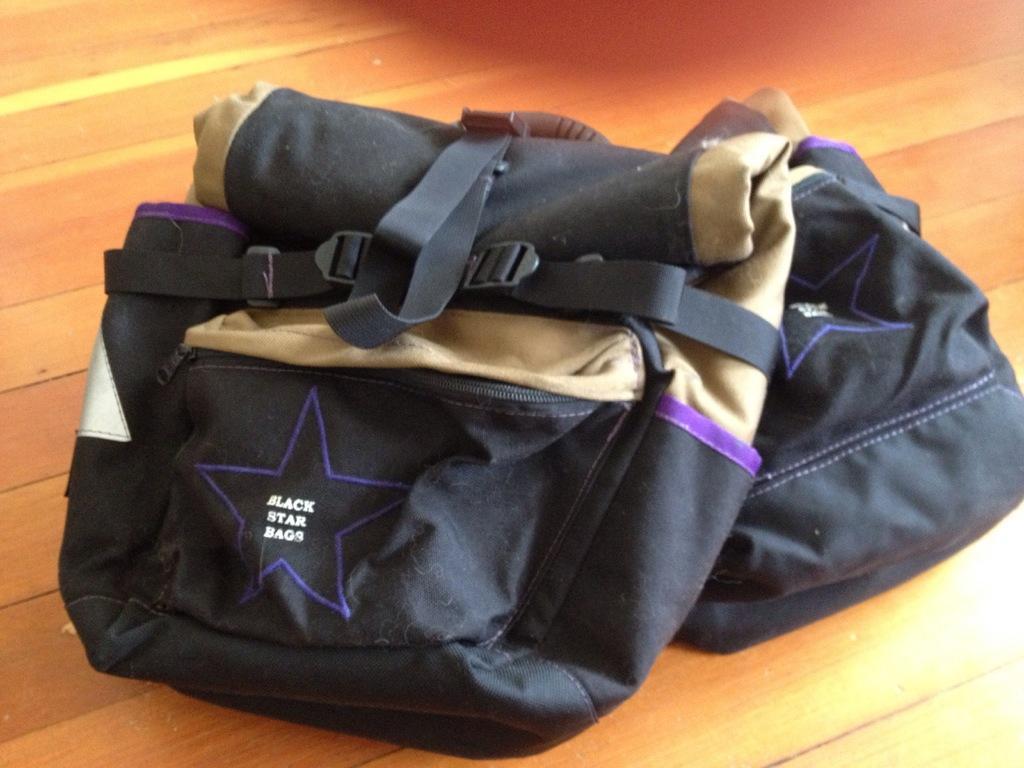Please provide a concise description of this image. In the picture there are are two bags kept on a wooden floor,they are of black and cream color. 